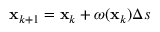Convert formula to latex. <formula><loc_0><loc_0><loc_500><loc_500>{ x } _ { k + 1 } = { x } _ { k } + \omega ( { x } _ { k } ) \Delta s</formula> 